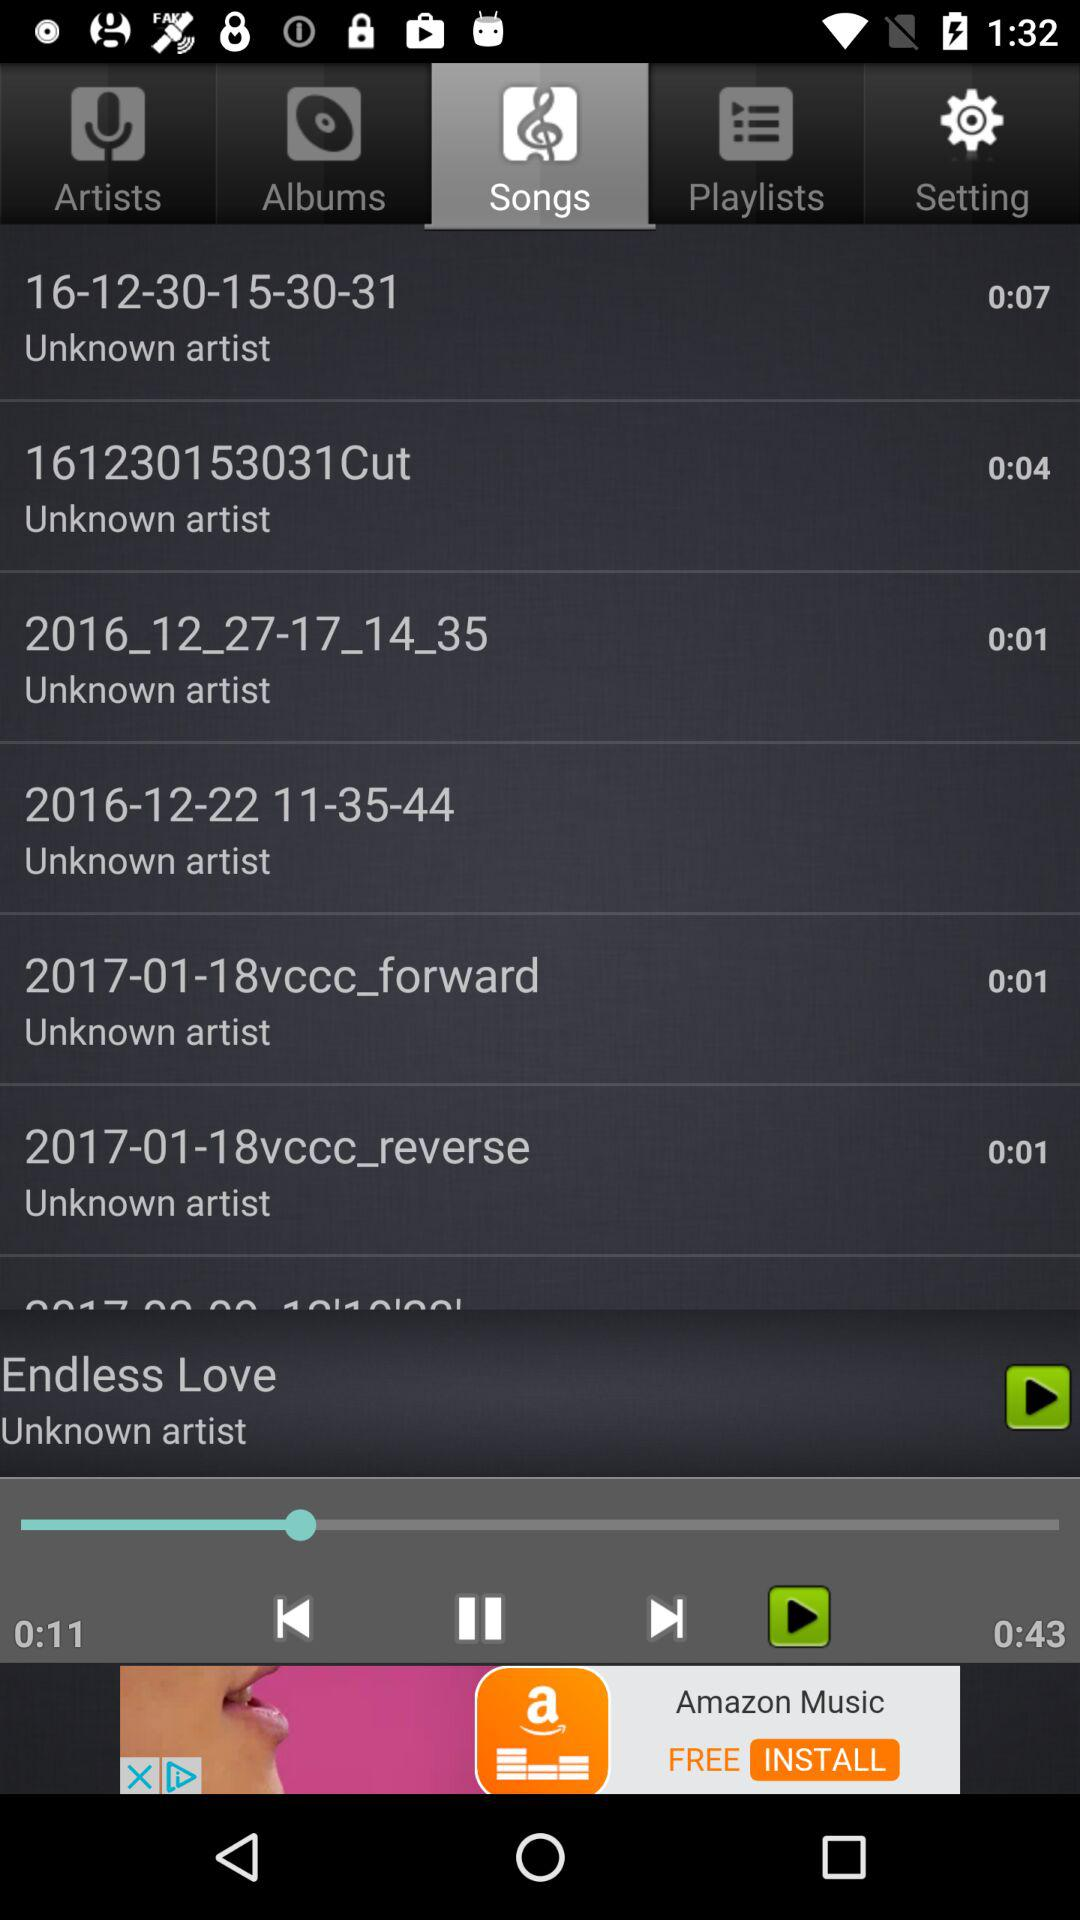Which option is selected? The selected option is "Songs". 